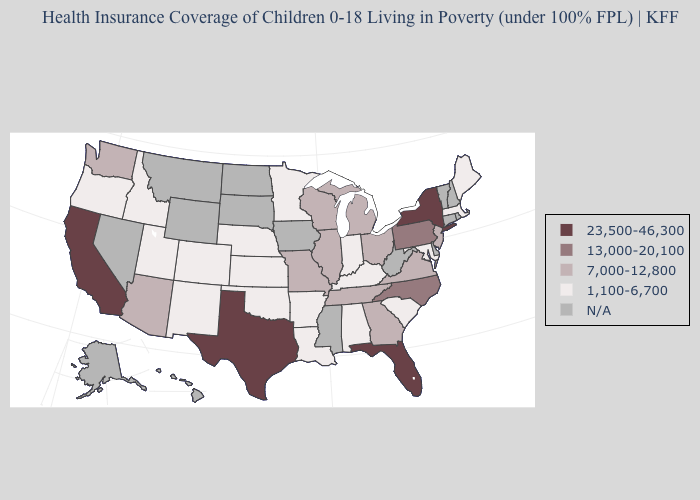What is the value of Maryland?
Concise answer only. 1,100-6,700. What is the value of Oregon?
Write a very short answer. 1,100-6,700. Name the states that have a value in the range 1,100-6,700?
Keep it brief. Alabama, Arkansas, Colorado, Idaho, Indiana, Kansas, Kentucky, Louisiana, Maine, Maryland, Massachusetts, Minnesota, Nebraska, New Mexico, Oklahoma, Oregon, South Carolina, Utah. Does New Jersey have the highest value in the Northeast?
Write a very short answer. No. Does New York have the highest value in the USA?
Write a very short answer. Yes. How many symbols are there in the legend?
Give a very brief answer. 5. Which states have the lowest value in the USA?
Quick response, please. Alabama, Arkansas, Colorado, Idaho, Indiana, Kansas, Kentucky, Louisiana, Maine, Maryland, Massachusetts, Minnesota, Nebraska, New Mexico, Oklahoma, Oregon, South Carolina, Utah. Does Nebraska have the lowest value in the MidWest?
Keep it brief. Yes. What is the value of Nebraska?
Give a very brief answer. 1,100-6,700. What is the lowest value in the USA?
Be succinct. 1,100-6,700. What is the value of Louisiana?
Write a very short answer. 1,100-6,700. Name the states that have a value in the range 13,000-20,100?
Answer briefly. North Carolina, Pennsylvania. Is the legend a continuous bar?
Short answer required. No. What is the highest value in the South ?
Answer briefly. 23,500-46,300. 